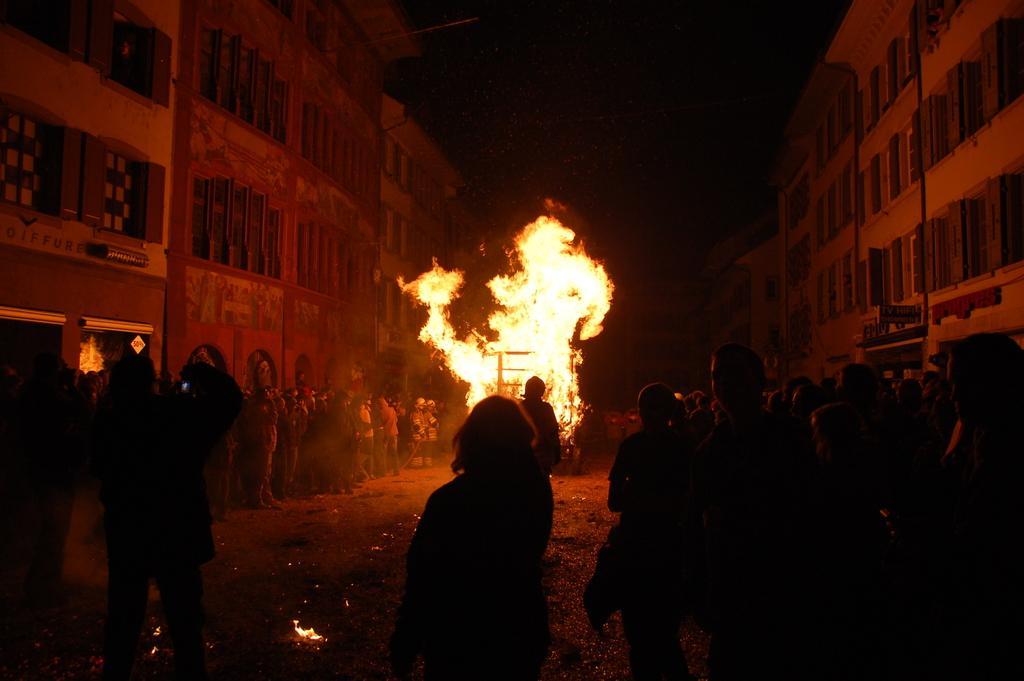In one or two sentences, can you explain what this image depicts? As we can see in the image there are buildings, fire and few people here and there. 